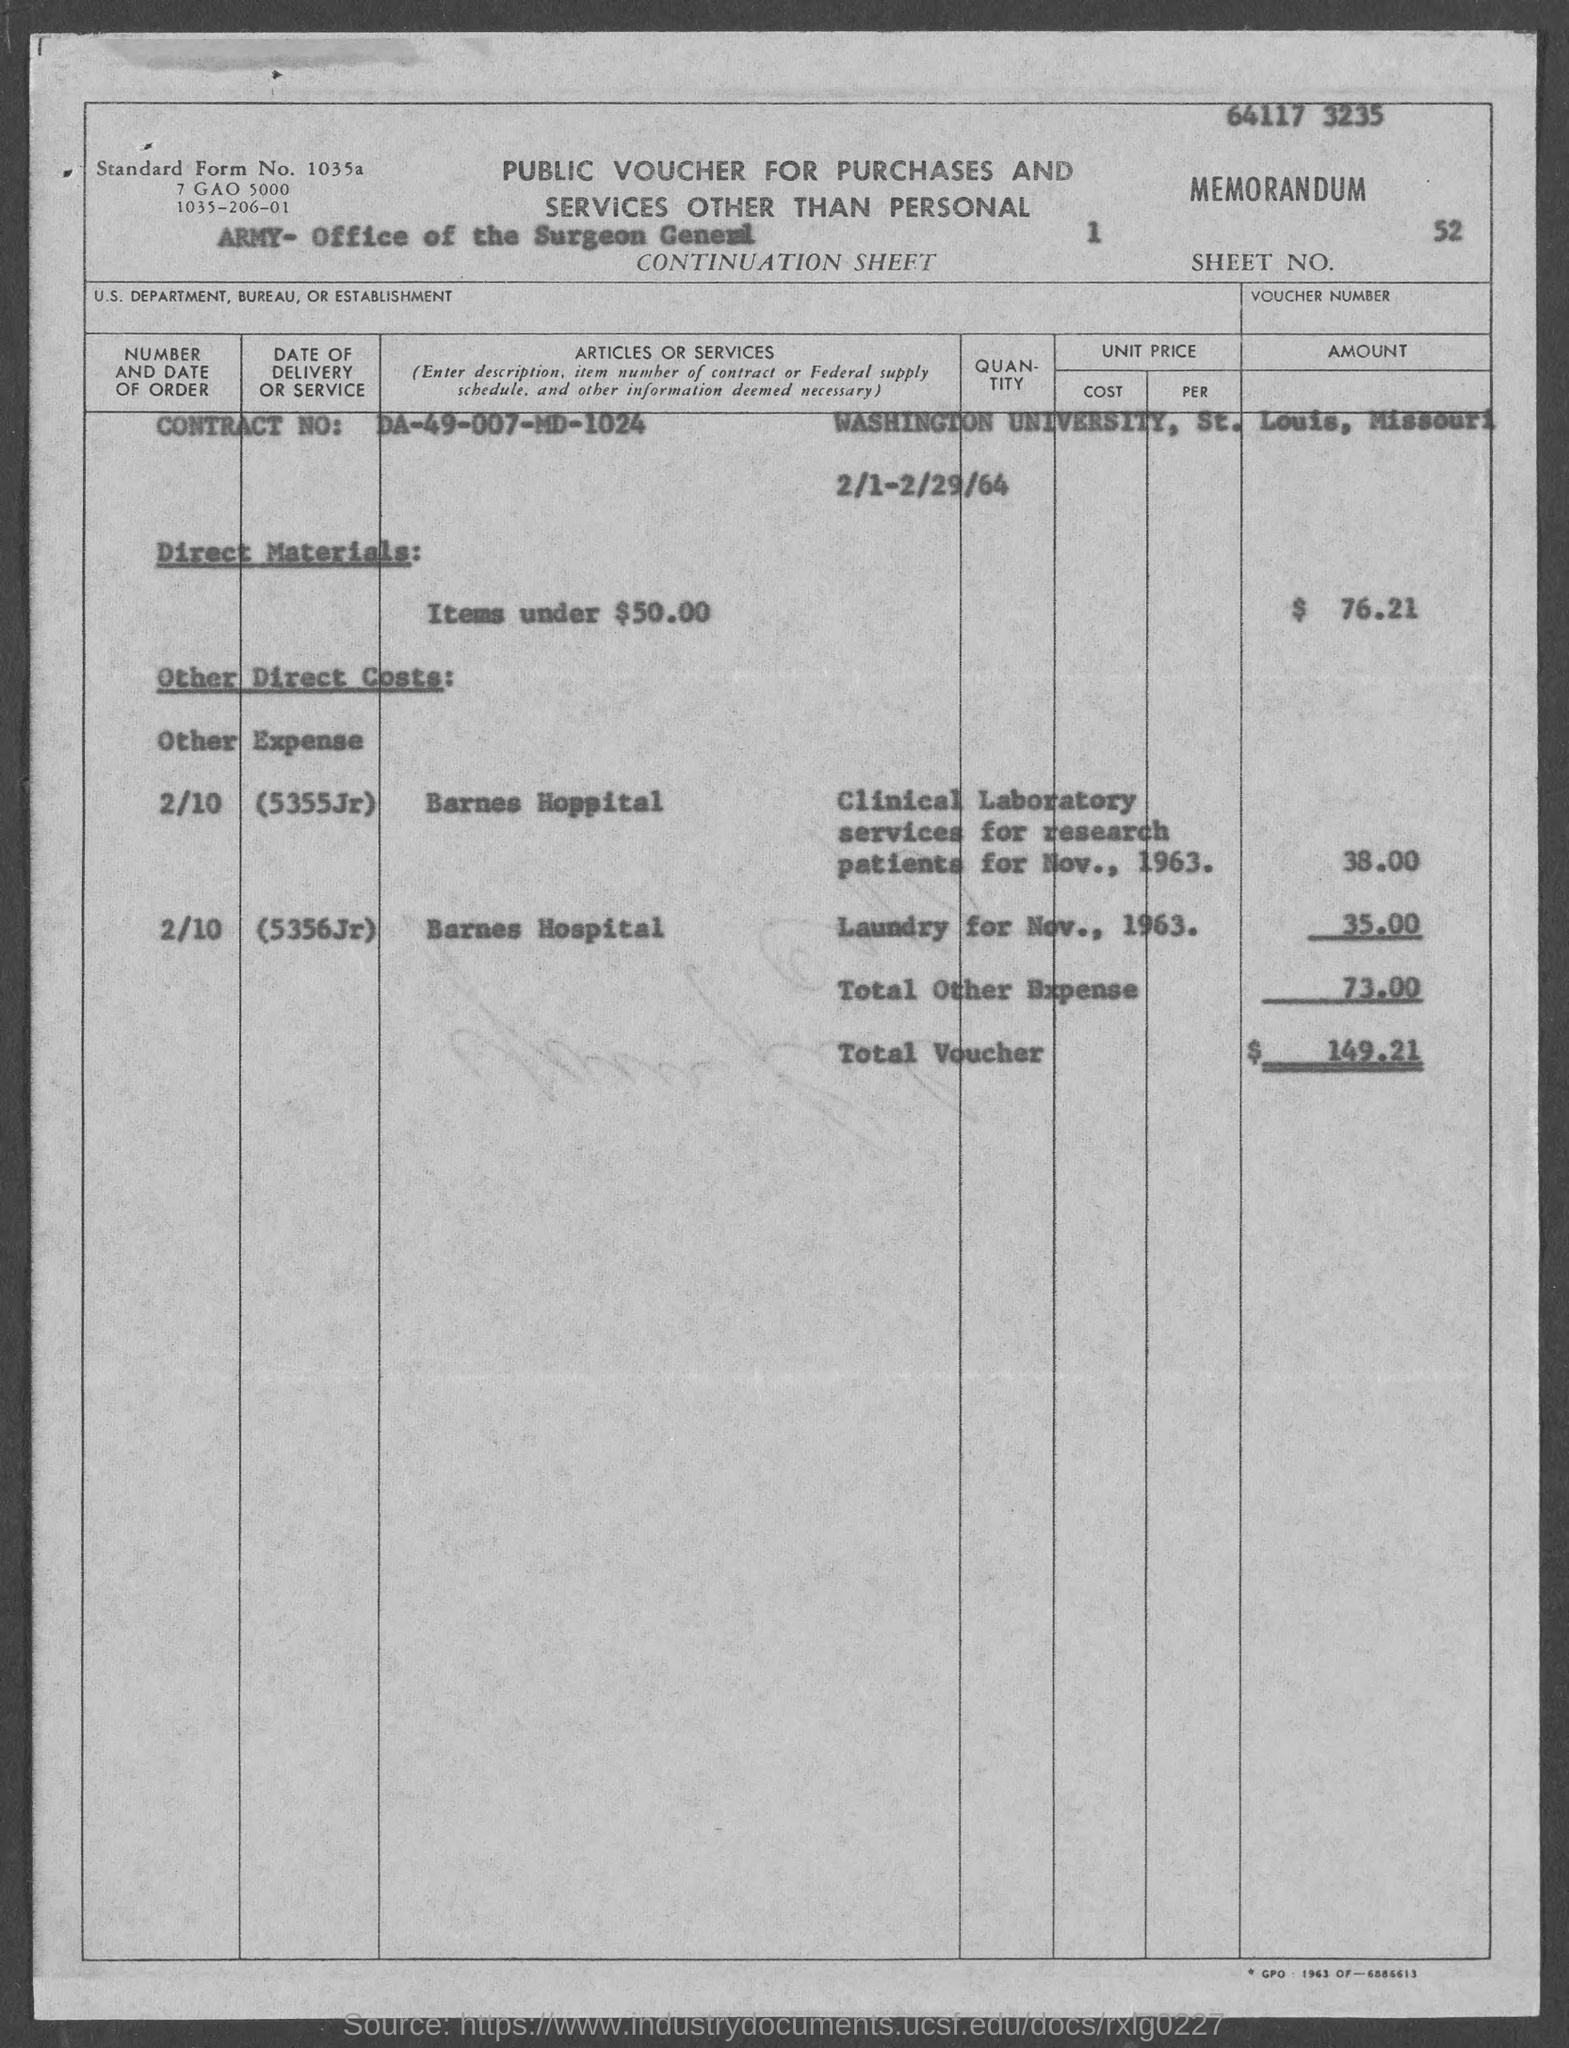What type of voucher is given here?
Your response must be concise. PUBLIC VOUCHER FOR PURCHASES AND SERVICES OTHER THAN PERSONAL. What is the Standard Form No. given in the voucher?
Give a very brief answer. 1035a. What is the Sheet No. mentioned in the voucher?
Your response must be concise. 1. What is the voucher number given in the document?
Offer a terse response. 52. What is the U.S. Department, Bureau, or Establishment given in the voucher?
Offer a very short reply. Army- office of the surgeon general. What is the Contract No. given in the voucher?
Provide a short and direct response. DA-49-007-MD-1024. What is the Direct material cost (Items under $50.00) given in the document?
Give a very brief answer. 76.21. What is the total voucher amount mentioned in the document?
Make the answer very short. $ 149.21. 